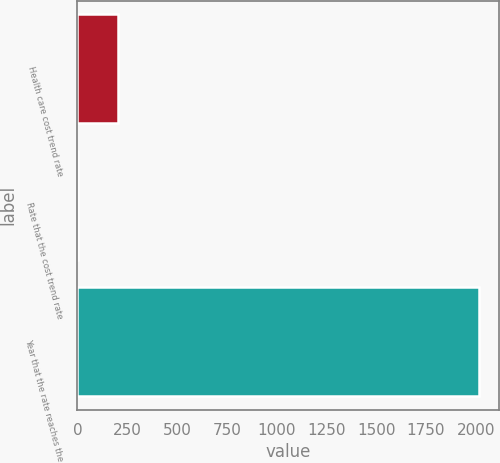<chart> <loc_0><loc_0><loc_500><loc_500><bar_chart><fcel>Health care cost trend rate<fcel>Rate that the cost trend rate<fcel>Year that the rate reaches the<nl><fcel>206.3<fcel>5<fcel>2018<nl></chart> 